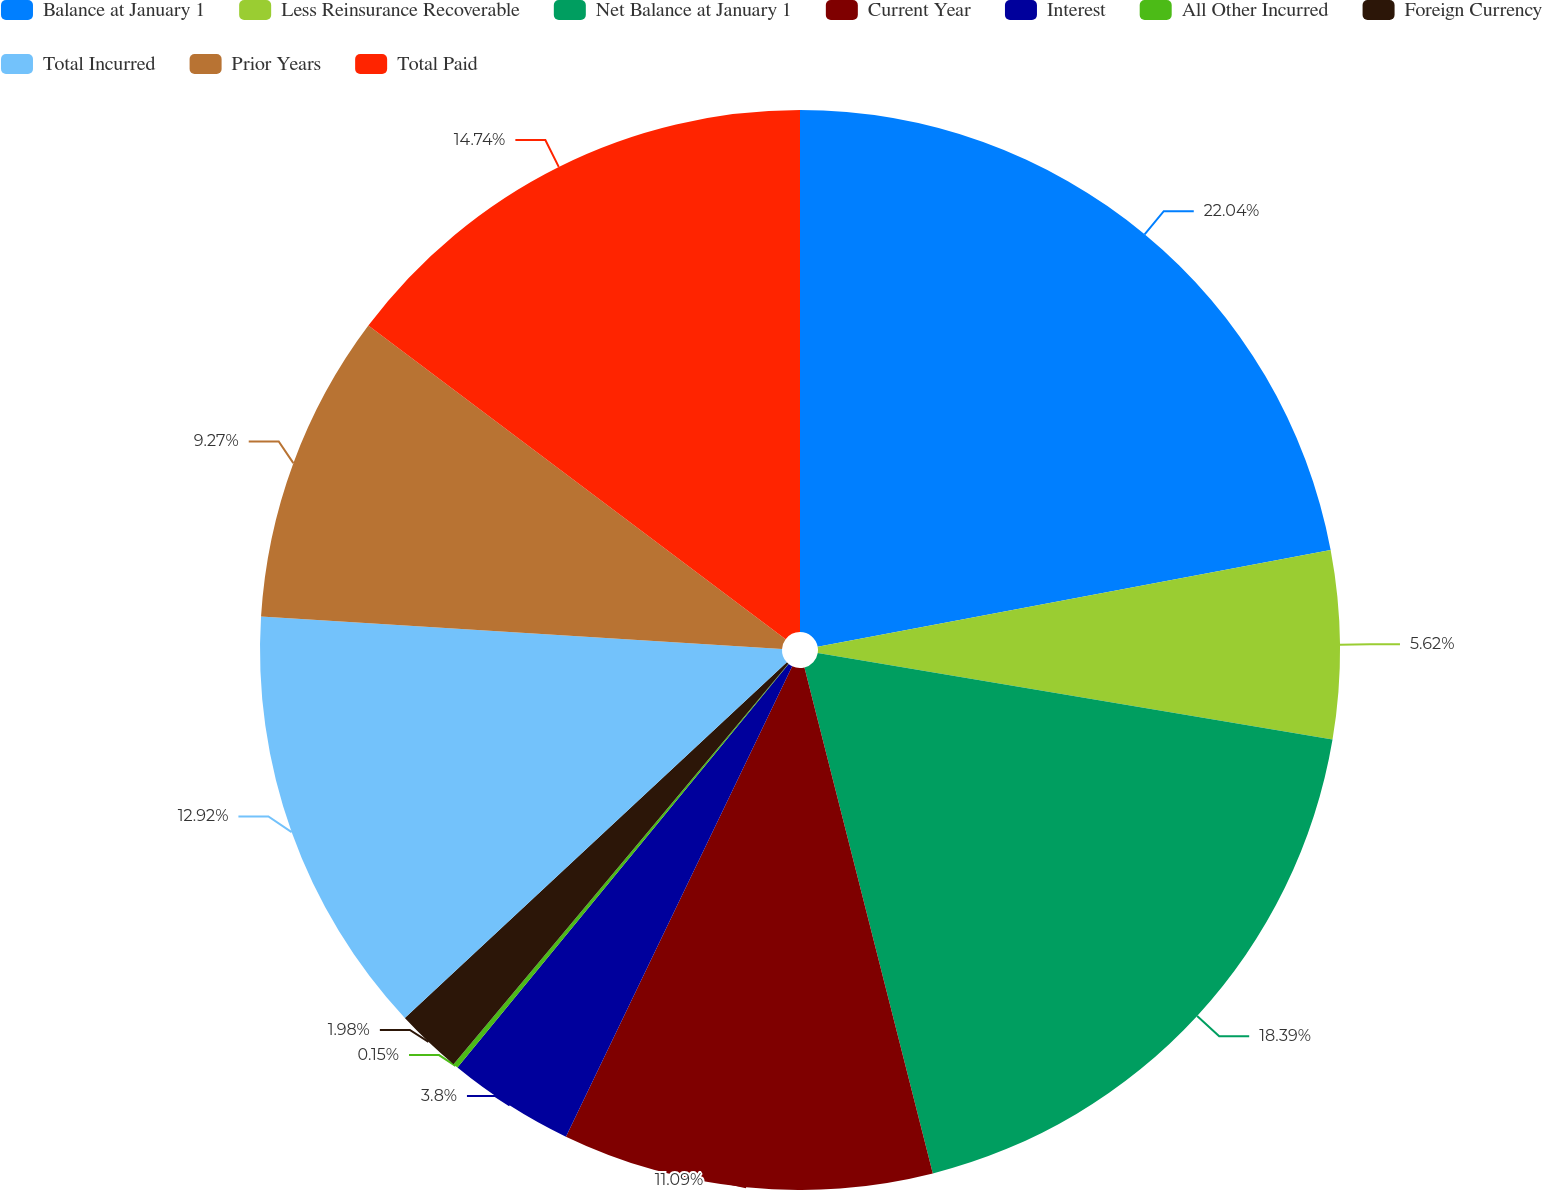<chart> <loc_0><loc_0><loc_500><loc_500><pie_chart><fcel>Balance at January 1<fcel>Less Reinsurance Recoverable<fcel>Net Balance at January 1<fcel>Current Year<fcel>Interest<fcel>All Other Incurred<fcel>Foreign Currency<fcel>Total Incurred<fcel>Prior Years<fcel>Total Paid<nl><fcel>22.03%<fcel>5.62%<fcel>18.39%<fcel>11.09%<fcel>3.8%<fcel>0.15%<fcel>1.98%<fcel>12.92%<fcel>9.27%<fcel>14.74%<nl></chart> 